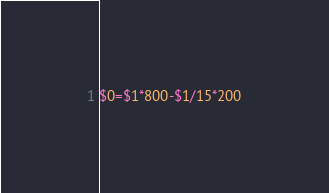Convert code to text. <code><loc_0><loc_0><loc_500><loc_500><_Awk_>$0=$1*800-$1/15*200</code> 